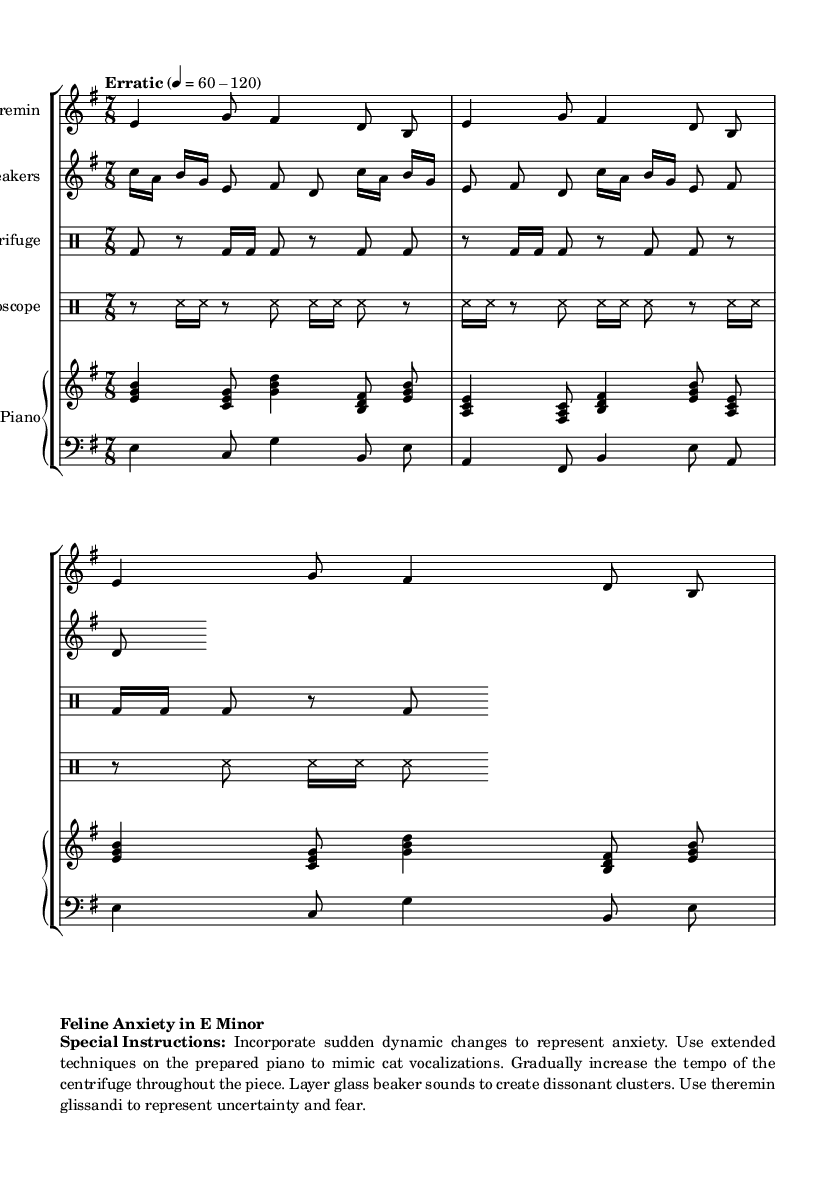What is the key signature of this music? The key signature is E minor, which has one sharp (F sharp). This can be determined from the "key e \minor" indication at the beginning of the score.
Answer: E minor What is the time signature of the piece? The time signature is 7/8, indicated in the score next to "time" in each staff. This means there are seven eighth notes per measure.
Answer: 7/8 How many staves are used for instruments in this score? There are five staves used, which are for the Theremin, Glass Beakers, Centrifuge, Stethoscope, and Prepared Piano, as designated in the score.
Answer: Five What is the tempo marking of the piece? The tempo marking is "Erratic", indicated at the beginning with a range from 60 to 120 beats per minute as noted next to "tempo".
Answer: Erratic What instruments are used in this work? The instruments include Theremin, Glass Beakers, Centrifuge, Stethoscope, and Prepared Piano. Each is clearly labeled in the score at the start of its respective staff.
Answer: Theremin, Glass Beakers, Centrifuge, Stethoscope, Prepared Piano What extended techniques are suggested for the prepared piano? The special instructions indicate to use extended techniques to mimic cat vocalizations. This aligns with the piece's theme of feline anxiety.
Answer: Mimic cat vocalizations What role does the centrifuge play in the piece? The centrifuge is indicated as a percussion instrument with rhythm notated in drum mode. The instructions state to gradually increase the tempo throughout the piece, suggesting a growing intensity.
Answer: Gradually increase tempo 